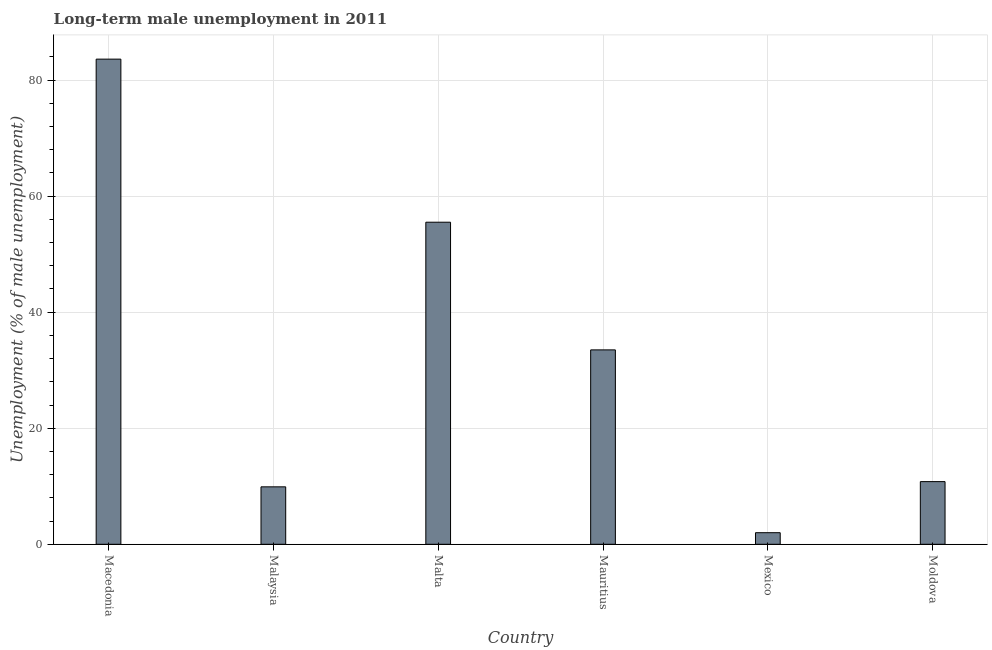Does the graph contain any zero values?
Your answer should be very brief. No. What is the title of the graph?
Give a very brief answer. Long-term male unemployment in 2011. What is the label or title of the X-axis?
Keep it short and to the point. Country. What is the label or title of the Y-axis?
Give a very brief answer. Unemployment (% of male unemployment). Across all countries, what is the maximum long-term male unemployment?
Provide a succinct answer. 83.6. Across all countries, what is the minimum long-term male unemployment?
Provide a short and direct response. 2. In which country was the long-term male unemployment maximum?
Your answer should be very brief. Macedonia. In which country was the long-term male unemployment minimum?
Give a very brief answer. Mexico. What is the sum of the long-term male unemployment?
Give a very brief answer. 195.3. What is the difference between the long-term male unemployment in Malta and Mexico?
Offer a terse response. 53.5. What is the average long-term male unemployment per country?
Offer a very short reply. 32.55. What is the median long-term male unemployment?
Your answer should be very brief. 22.15. What is the ratio of the long-term male unemployment in Macedonia to that in Malta?
Provide a short and direct response. 1.51. What is the difference between the highest and the second highest long-term male unemployment?
Your response must be concise. 28.1. Is the sum of the long-term male unemployment in Malaysia and Moldova greater than the maximum long-term male unemployment across all countries?
Provide a short and direct response. No. What is the difference between the highest and the lowest long-term male unemployment?
Give a very brief answer. 81.6. In how many countries, is the long-term male unemployment greater than the average long-term male unemployment taken over all countries?
Provide a succinct answer. 3. How many bars are there?
Provide a succinct answer. 6. Are all the bars in the graph horizontal?
Make the answer very short. No. How many countries are there in the graph?
Your answer should be very brief. 6. Are the values on the major ticks of Y-axis written in scientific E-notation?
Give a very brief answer. No. What is the Unemployment (% of male unemployment) in Macedonia?
Your response must be concise. 83.6. What is the Unemployment (% of male unemployment) of Malaysia?
Your answer should be compact. 9.9. What is the Unemployment (% of male unemployment) in Malta?
Give a very brief answer. 55.5. What is the Unemployment (% of male unemployment) in Mauritius?
Keep it short and to the point. 33.5. What is the Unemployment (% of male unemployment) of Mexico?
Your answer should be compact. 2. What is the Unemployment (% of male unemployment) in Moldova?
Give a very brief answer. 10.8. What is the difference between the Unemployment (% of male unemployment) in Macedonia and Malaysia?
Make the answer very short. 73.7. What is the difference between the Unemployment (% of male unemployment) in Macedonia and Malta?
Keep it short and to the point. 28.1. What is the difference between the Unemployment (% of male unemployment) in Macedonia and Mauritius?
Make the answer very short. 50.1. What is the difference between the Unemployment (% of male unemployment) in Macedonia and Mexico?
Your response must be concise. 81.6. What is the difference between the Unemployment (% of male unemployment) in Macedonia and Moldova?
Provide a succinct answer. 72.8. What is the difference between the Unemployment (% of male unemployment) in Malaysia and Malta?
Give a very brief answer. -45.6. What is the difference between the Unemployment (% of male unemployment) in Malaysia and Mauritius?
Provide a short and direct response. -23.6. What is the difference between the Unemployment (% of male unemployment) in Malaysia and Mexico?
Offer a terse response. 7.9. What is the difference between the Unemployment (% of male unemployment) in Malta and Mexico?
Give a very brief answer. 53.5. What is the difference between the Unemployment (% of male unemployment) in Malta and Moldova?
Keep it short and to the point. 44.7. What is the difference between the Unemployment (% of male unemployment) in Mauritius and Mexico?
Offer a very short reply. 31.5. What is the difference between the Unemployment (% of male unemployment) in Mauritius and Moldova?
Your answer should be compact. 22.7. What is the difference between the Unemployment (% of male unemployment) in Mexico and Moldova?
Offer a very short reply. -8.8. What is the ratio of the Unemployment (% of male unemployment) in Macedonia to that in Malaysia?
Your answer should be very brief. 8.44. What is the ratio of the Unemployment (% of male unemployment) in Macedonia to that in Malta?
Ensure brevity in your answer.  1.51. What is the ratio of the Unemployment (% of male unemployment) in Macedonia to that in Mauritius?
Make the answer very short. 2.5. What is the ratio of the Unemployment (% of male unemployment) in Macedonia to that in Mexico?
Make the answer very short. 41.8. What is the ratio of the Unemployment (% of male unemployment) in Macedonia to that in Moldova?
Your response must be concise. 7.74. What is the ratio of the Unemployment (% of male unemployment) in Malaysia to that in Malta?
Give a very brief answer. 0.18. What is the ratio of the Unemployment (% of male unemployment) in Malaysia to that in Mauritius?
Your response must be concise. 0.3. What is the ratio of the Unemployment (% of male unemployment) in Malaysia to that in Mexico?
Provide a short and direct response. 4.95. What is the ratio of the Unemployment (% of male unemployment) in Malaysia to that in Moldova?
Your answer should be very brief. 0.92. What is the ratio of the Unemployment (% of male unemployment) in Malta to that in Mauritius?
Ensure brevity in your answer.  1.66. What is the ratio of the Unemployment (% of male unemployment) in Malta to that in Mexico?
Keep it short and to the point. 27.75. What is the ratio of the Unemployment (% of male unemployment) in Malta to that in Moldova?
Provide a short and direct response. 5.14. What is the ratio of the Unemployment (% of male unemployment) in Mauritius to that in Mexico?
Keep it short and to the point. 16.75. What is the ratio of the Unemployment (% of male unemployment) in Mauritius to that in Moldova?
Ensure brevity in your answer.  3.1. What is the ratio of the Unemployment (% of male unemployment) in Mexico to that in Moldova?
Offer a terse response. 0.18. 